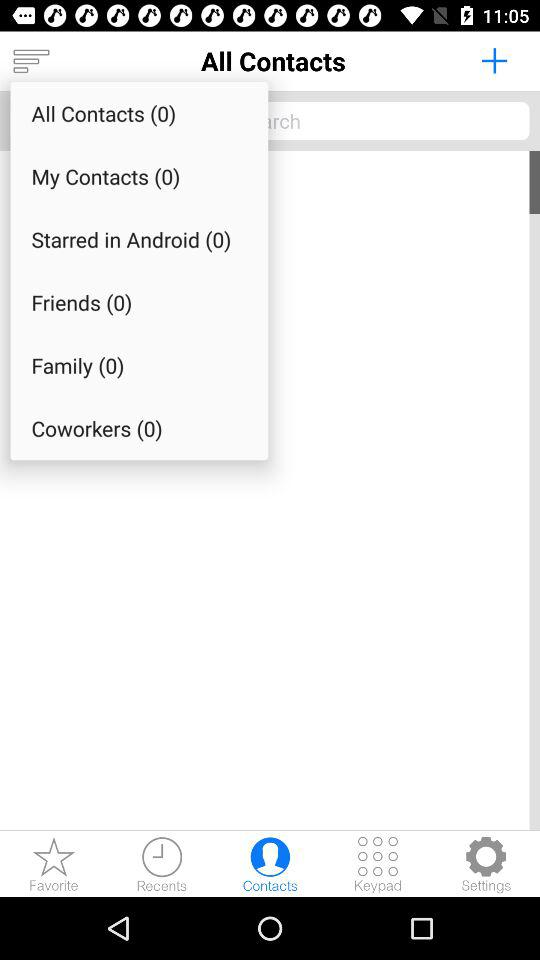How many items are there in total in "All Contacts"? There are 0 items in total in "All Contacts". 